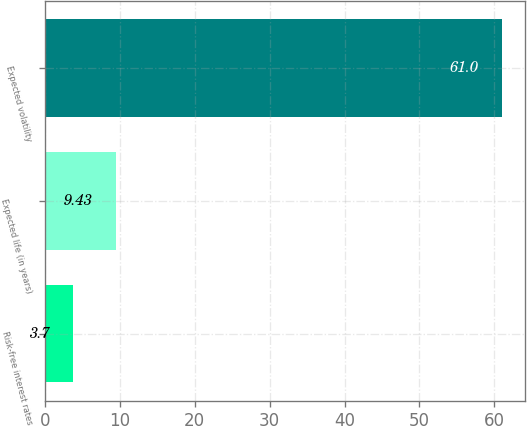<chart> <loc_0><loc_0><loc_500><loc_500><bar_chart><fcel>Risk-free interest rates<fcel>Expected life (in years)<fcel>Expected volatility<nl><fcel>3.7<fcel>9.43<fcel>61<nl></chart> 